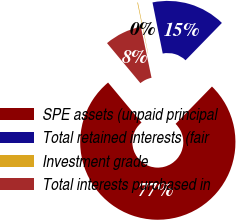Convert chart to OTSL. <chart><loc_0><loc_0><loc_500><loc_500><pie_chart><fcel>SPE assets (unpaid principal<fcel>Total retained interests (fair<fcel>Investment grade<fcel>Total interests purchased in<nl><fcel>76.64%<fcel>15.44%<fcel>0.13%<fcel>7.79%<nl></chart> 